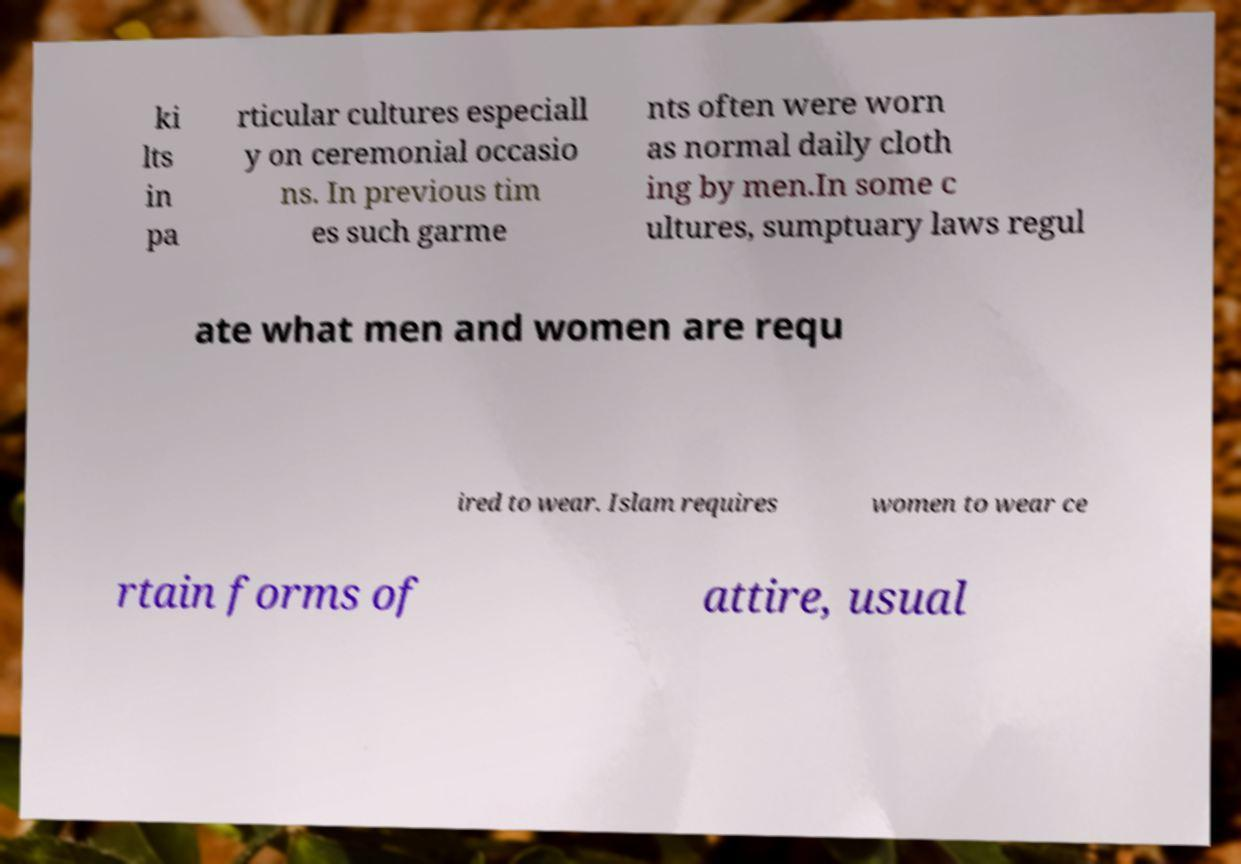Can you read and provide the text displayed in the image?This photo seems to have some interesting text. Can you extract and type it out for me? ki lts in pa rticular cultures especiall y on ceremonial occasio ns. In previous tim es such garme nts often were worn as normal daily cloth ing by men.In some c ultures, sumptuary laws regul ate what men and women are requ ired to wear. Islam requires women to wear ce rtain forms of attire, usual 